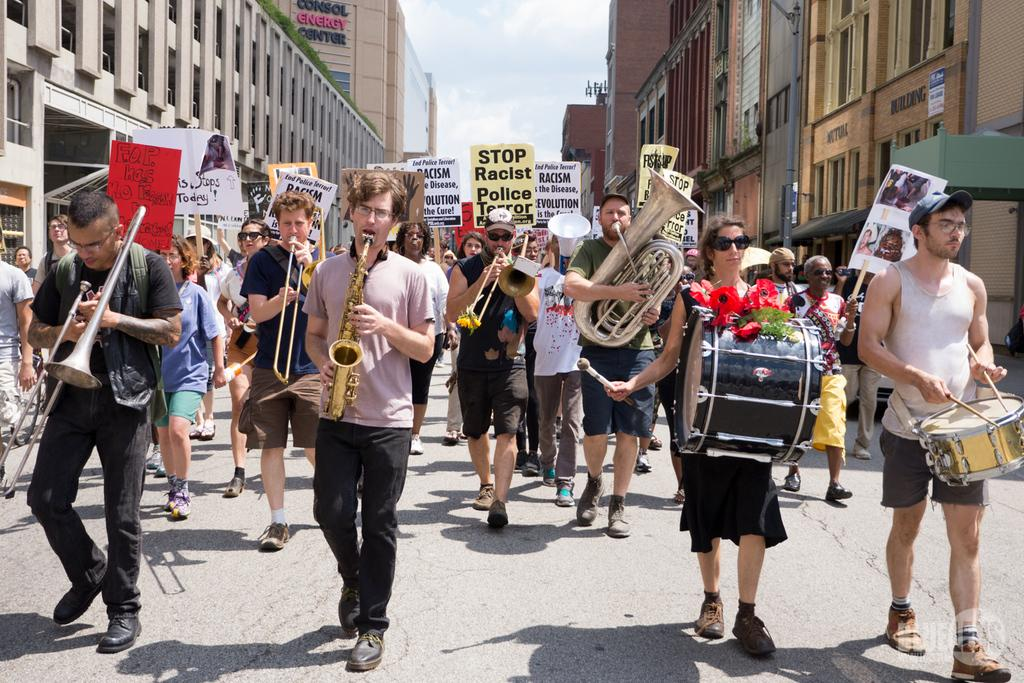What can be seen in the background of the image? There is a sky in the image. What is hanging or displayed in the image? There is a banner in the image. What type of structures are present in the image? There are buildings in the image. What are the people in the image doing? People are walking on the road and playing different types of musical instruments in the image. Where is the basket located in the image? There is no basket present in the image. What type of art can be seen on the banner in the image? The provided facts do not mention any specific art on the banner, so we cannot answer that question. 